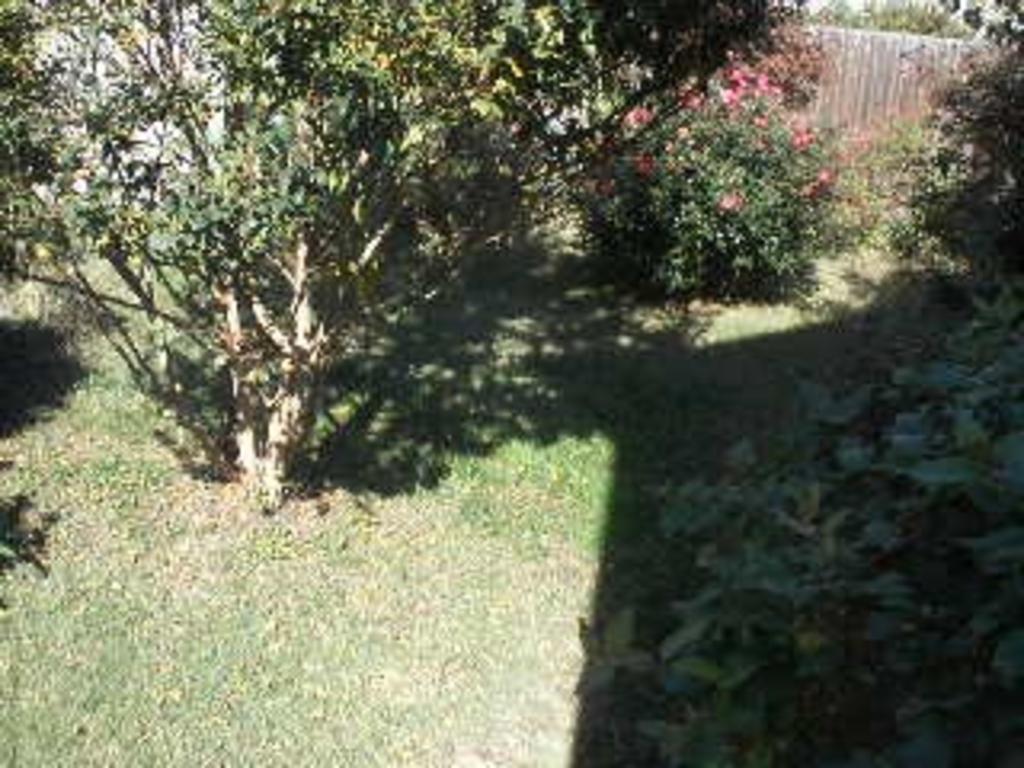Can you describe this image briefly? In this picture, we can see the ground, grass, plants, trees, and we can see some object in the background. 